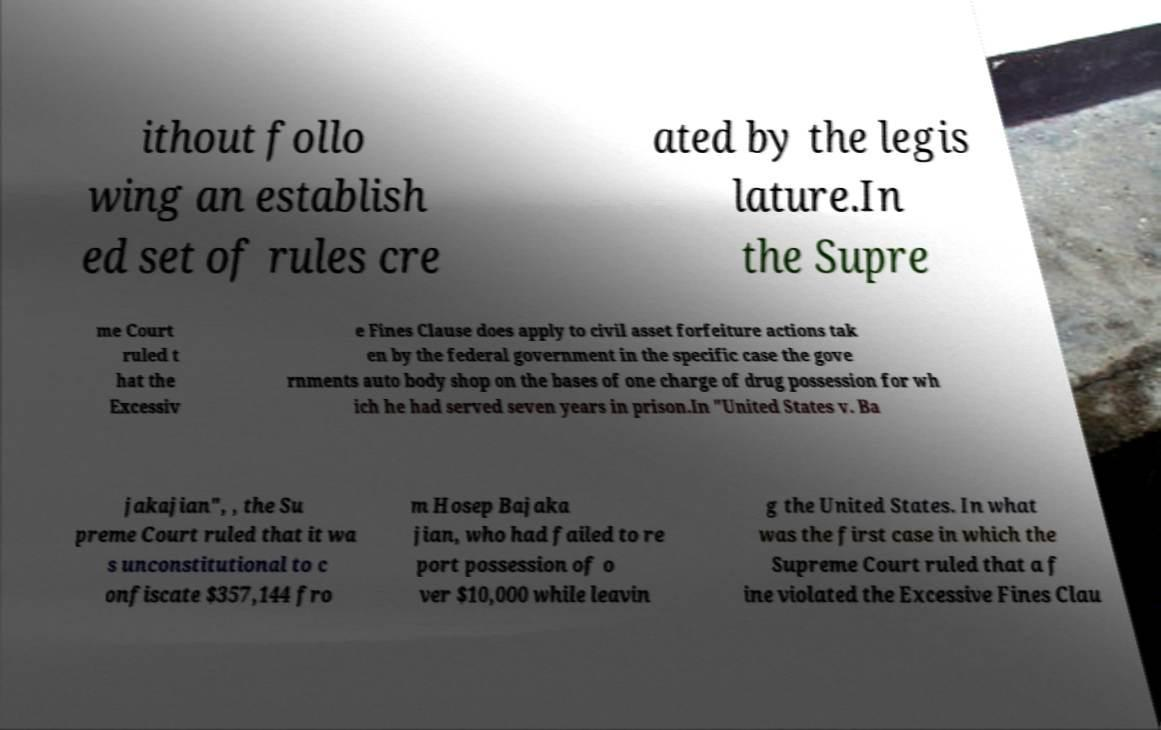Please identify and transcribe the text found in this image. ithout follo wing an establish ed set of rules cre ated by the legis lature.In the Supre me Court ruled t hat the Excessiv e Fines Clause does apply to civil asset forfeiture actions tak en by the federal government in the specific case the gove rnments auto body shop on the bases of one charge of drug possession for wh ich he had served seven years in prison.In "United States v. Ba jakajian", , the Su preme Court ruled that it wa s unconstitutional to c onfiscate $357,144 fro m Hosep Bajaka jian, who had failed to re port possession of o ver $10,000 while leavin g the United States. In what was the first case in which the Supreme Court ruled that a f ine violated the Excessive Fines Clau 